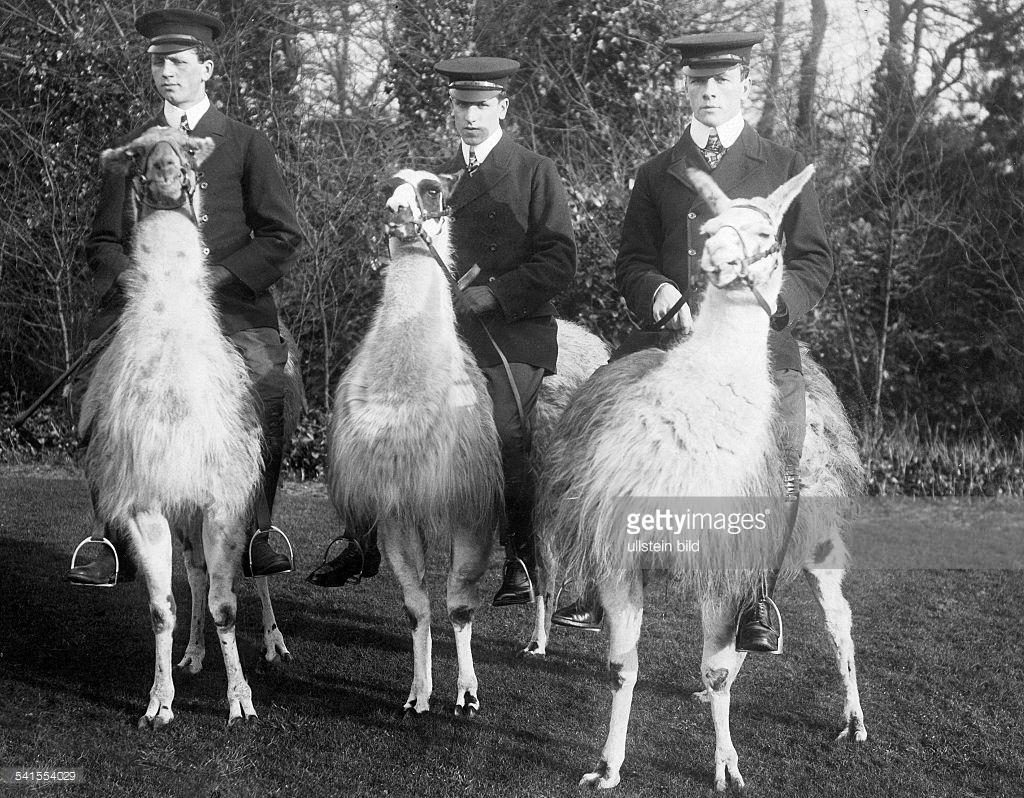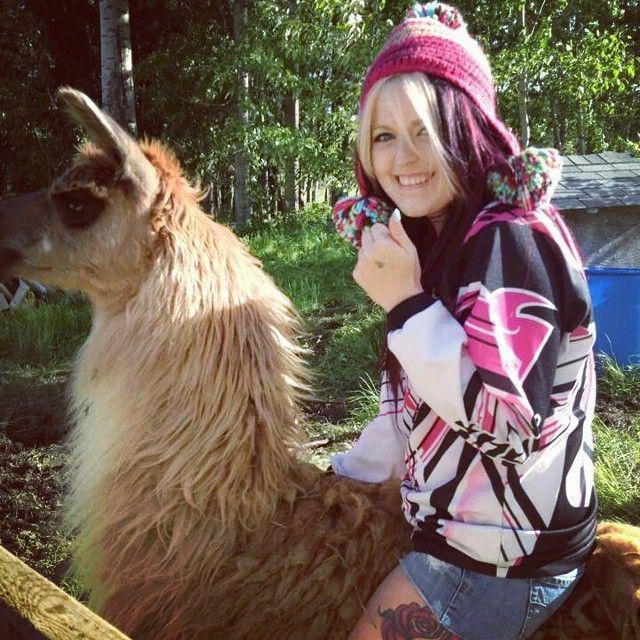The first image is the image on the left, the second image is the image on the right. Examine the images to the left and right. Is the description "There are humans riding the llamas." accurate? Answer yes or no. Yes. The first image is the image on the left, the second image is the image on the right. Analyze the images presented: Is the assertion "At least one person can be seen riding a llama." valid? Answer yes or no. Yes. 